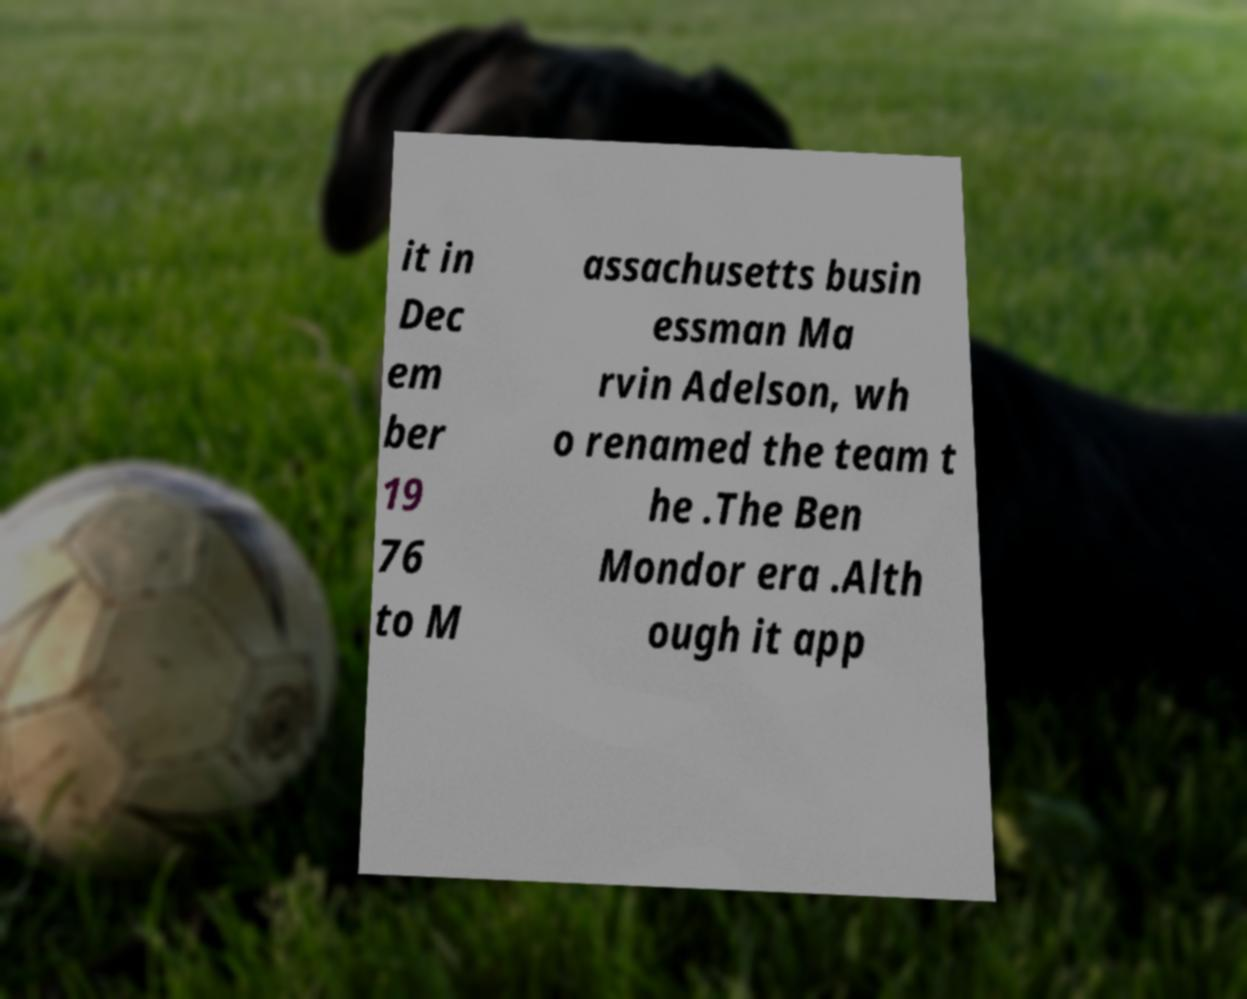What messages or text are displayed in this image? I need them in a readable, typed format. it in Dec em ber 19 76 to M assachusetts busin essman Ma rvin Adelson, wh o renamed the team t he .The Ben Mondor era .Alth ough it app 